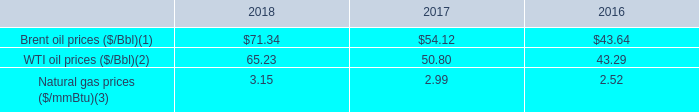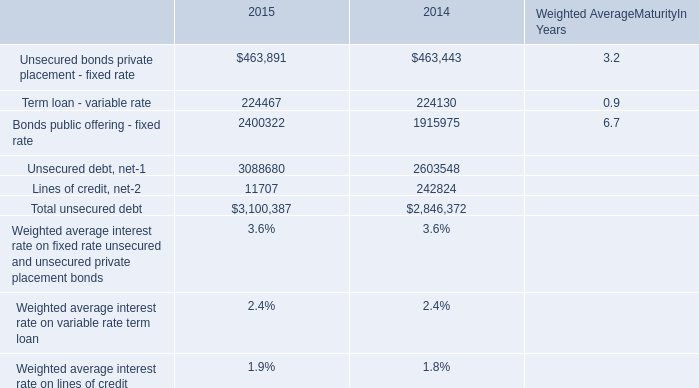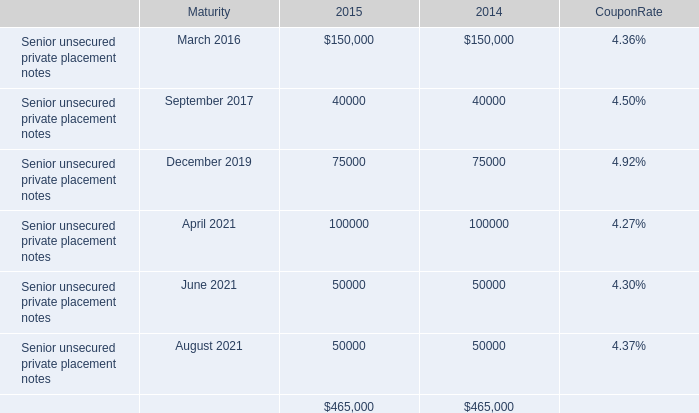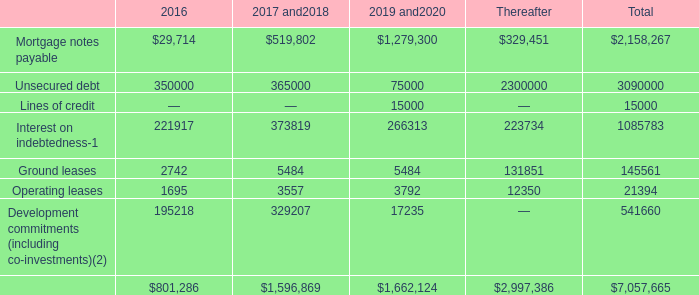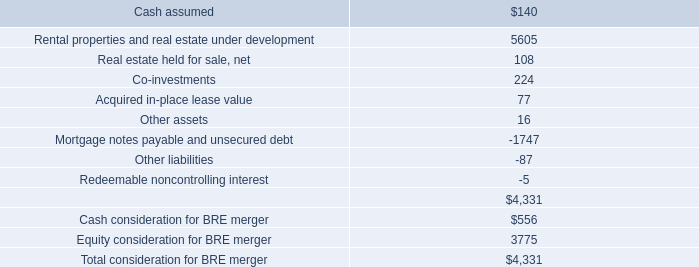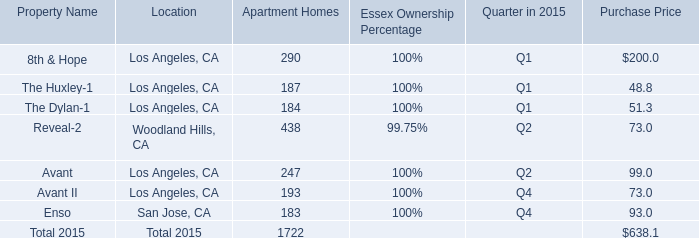what is the growth rate in brent oil prices from 2016 to 2017? 
Computations: ((54.12 - 43.64) / 43.64)
Answer: 0.24015. 